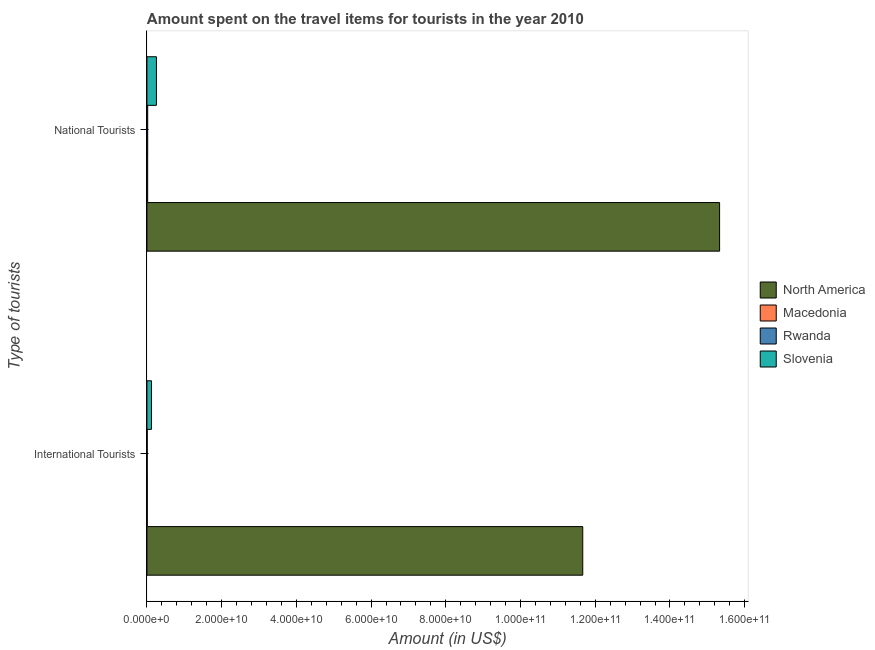How many groups of bars are there?
Offer a terse response. 2. How many bars are there on the 1st tick from the top?
Your response must be concise. 4. What is the label of the 1st group of bars from the top?
Keep it short and to the point. National Tourists. What is the amount spent on travel items of international tourists in Macedonia?
Provide a succinct answer. 9.20e+07. Across all countries, what is the maximum amount spent on travel items of national tourists?
Your answer should be compact. 1.53e+11. Across all countries, what is the minimum amount spent on travel items of international tourists?
Offer a terse response. 7.70e+07. In which country was the amount spent on travel items of national tourists minimum?
Make the answer very short. Macedonia. What is the total amount spent on travel items of international tourists in the graph?
Ensure brevity in your answer.  1.18e+11. What is the difference between the amount spent on travel items of national tourists in Rwanda and that in Slovenia?
Offer a very short reply. -2.34e+09. What is the difference between the amount spent on travel items of national tourists in North America and the amount spent on travel items of international tourists in Slovenia?
Your answer should be very brief. 1.52e+11. What is the average amount spent on travel items of international tourists per country?
Offer a very short reply. 2.95e+1. What is the difference between the amount spent on travel items of international tourists and amount spent on travel items of national tourists in North America?
Your answer should be very brief. -3.66e+1. What is the ratio of the amount spent on travel items of international tourists in Rwanda to that in Macedonia?
Offer a terse response. 0.84. In how many countries, is the amount spent on travel items of international tourists greater than the average amount spent on travel items of international tourists taken over all countries?
Your response must be concise. 1. What does the 1st bar from the top in International Tourists represents?
Offer a very short reply. Slovenia. What does the 4th bar from the bottom in International Tourists represents?
Your response must be concise. Slovenia. Are all the bars in the graph horizontal?
Your response must be concise. Yes. How many countries are there in the graph?
Your answer should be compact. 4. What is the difference between two consecutive major ticks on the X-axis?
Provide a succinct answer. 2.00e+1. Where does the legend appear in the graph?
Make the answer very short. Center right. How are the legend labels stacked?
Provide a short and direct response. Vertical. What is the title of the graph?
Offer a very short reply. Amount spent on the travel items for tourists in the year 2010. What is the label or title of the X-axis?
Make the answer very short. Amount (in US$). What is the label or title of the Y-axis?
Give a very brief answer. Type of tourists. What is the Amount (in US$) in North America in International Tourists?
Your response must be concise. 1.17e+11. What is the Amount (in US$) in Macedonia in International Tourists?
Your response must be concise. 9.20e+07. What is the Amount (in US$) of Rwanda in International Tourists?
Give a very brief answer. 7.70e+07. What is the Amount (in US$) of Slovenia in International Tourists?
Provide a succinct answer. 1.21e+09. What is the Amount (in US$) in North America in National Tourists?
Your answer should be compact. 1.53e+11. What is the Amount (in US$) of Macedonia in National Tourists?
Your answer should be compact. 1.97e+08. What is the Amount (in US$) of Rwanda in National Tourists?
Offer a very short reply. 2.02e+08. What is the Amount (in US$) of Slovenia in National Tourists?
Make the answer very short. 2.54e+09. Across all Type of tourists, what is the maximum Amount (in US$) of North America?
Ensure brevity in your answer.  1.53e+11. Across all Type of tourists, what is the maximum Amount (in US$) of Macedonia?
Your answer should be very brief. 1.97e+08. Across all Type of tourists, what is the maximum Amount (in US$) of Rwanda?
Make the answer very short. 2.02e+08. Across all Type of tourists, what is the maximum Amount (in US$) of Slovenia?
Offer a terse response. 2.54e+09. Across all Type of tourists, what is the minimum Amount (in US$) in North America?
Make the answer very short. 1.17e+11. Across all Type of tourists, what is the minimum Amount (in US$) in Macedonia?
Make the answer very short. 9.20e+07. Across all Type of tourists, what is the minimum Amount (in US$) of Rwanda?
Your answer should be very brief. 7.70e+07. Across all Type of tourists, what is the minimum Amount (in US$) of Slovenia?
Make the answer very short. 1.21e+09. What is the total Amount (in US$) of North America in the graph?
Your answer should be compact. 2.70e+11. What is the total Amount (in US$) in Macedonia in the graph?
Give a very brief answer. 2.89e+08. What is the total Amount (in US$) of Rwanda in the graph?
Offer a very short reply. 2.79e+08. What is the total Amount (in US$) in Slovenia in the graph?
Your answer should be very brief. 3.75e+09. What is the difference between the Amount (in US$) of North America in International Tourists and that in National Tourists?
Offer a very short reply. -3.66e+1. What is the difference between the Amount (in US$) in Macedonia in International Tourists and that in National Tourists?
Offer a terse response. -1.05e+08. What is the difference between the Amount (in US$) of Rwanda in International Tourists and that in National Tourists?
Give a very brief answer. -1.25e+08. What is the difference between the Amount (in US$) of Slovenia in International Tourists and that in National Tourists?
Your response must be concise. -1.33e+09. What is the difference between the Amount (in US$) in North America in International Tourists and the Amount (in US$) in Macedonia in National Tourists?
Make the answer very short. 1.16e+11. What is the difference between the Amount (in US$) in North America in International Tourists and the Amount (in US$) in Rwanda in National Tourists?
Give a very brief answer. 1.16e+11. What is the difference between the Amount (in US$) in North America in International Tourists and the Amount (in US$) in Slovenia in National Tourists?
Make the answer very short. 1.14e+11. What is the difference between the Amount (in US$) in Macedonia in International Tourists and the Amount (in US$) in Rwanda in National Tourists?
Your response must be concise. -1.10e+08. What is the difference between the Amount (in US$) in Macedonia in International Tourists and the Amount (in US$) in Slovenia in National Tourists?
Provide a succinct answer. -2.45e+09. What is the difference between the Amount (in US$) of Rwanda in International Tourists and the Amount (in US$) of Slovenia in National Tourists?
Make the answer very short. -2.46e+09. What is the average Amount (in US$) in North America per Type of tourists?
Offer a terse response. 1.35e+11. What is the average Amount (in US$) in Macedonia per Type of tourists?
Offer a very short reply. 1.44e+08. What is the average Amount (in US$) of Rwanda per Type of tourists?
Keep it short and to the point. 1.40e+08. What is the average Amount (in US$) in Slovenia per Type of tourists?
Make the answer very short. 1.88e+09. What is the difference between the Amount (in US$) in North America and Amount (in US$) in Macedonia in International Tourists?
Provide a succinct answer. 1.17e+11. What is the difference between the Amount (in US$) in North America and Amount (in US$) in Rwanda in International Tourists?
Offer a very short reply. 1.17e+11. What is the difference between the Amount (in US$) in North America and Amount (in US$) in Slovenia in International Tourists?
Provide a short and direct response. 1.15e+11. What is the difference between the Amount (in US$) in Macedonia and Amount (in US$) in Rwanda in International Tourists?
Make the answer very short. 1.50e+07. What is the difference between the Amount (in US$) of Macedonia and Amount (in US$) of Slovenia in International Tourists?
Offer a terse response. -1.12e+09. What is the difference between the Amount (in US$) in Rwanda and Amount (in US$) in Slovenia in International Tourists?
Provide a short and direct response. -1.14e+09. What is the difference between the Amount (in US$) of North America and Amount (in US$) of Macedonia in National Tourists?
Provide a succinct answer. 1.53e+11. What is the difference between the Amount (in US$) of North America and Amount (in US$) of Rwanda in National Tourists?
Provide a short and direct response. 1.53e+11. What is the difference between the Amount (in US$) of North America and Amount (in US$) of Slovenia in National Tourists?
Provide a short and direct response. 1.51e+11. What is the difference between the Amount (in US$) in Macedonia and Amount (in US$) in Rwanda in National Tourists?
Offer a very short reply. -5.00e+06. What is the difference between the Amount (in US$) of Macedonia and Amount (in US$) of Slovenia in National Tourists?
Provide a succinct answer. -2.34e+09. What is the difference between the Amount (in US$) of Rwanda and Amount (in US$) of Slovenia in National Tourists?
Give a very brief answer. -2.34e+09. What is the ratio of the Amount (in US$) in North America in International Tourists to that in National Tourists?
Your answer should be very brief. 0.76. What is the ratio of the Amount (in US$) of Macedonia in International Tourists to that in National Tourists?
Keep it short and to the point. 0.47. What is the ratio of the Amount (in US$) in Rwanda in International Tourists to that in National Tourists?
Ensure brevity in your answer.  0.38. What is the ratio of the Amount (in US$) in Slovenia in International Tourists to that in National Tourists?
Provide a short and direct response. 0.48. What is the difference between the highest and the second highest Amount (in US$) of North America?
Offer a terse response. 3.66e+1. What is the difference between the highest and the second highest Amount (in US$) of Macedonia?
Ensure brevity in your answer.  1.05e+08. What is the difference between the highest and the second highest Amount (in US$) in Rwanda?
Your answer should be compact. 1.25e+08. What is the difference between the highest and the second highest Amount (in US$) of Slovenia?
Provide a short and direct response. 1.33e+09. What is the difference between the highest and the lowest Amount (in US$) of North America?
Offer a very short reply. 3.66e+1. What is the difference between the highest and the lowest Amount (in US$) in Macedonia?
Provide a short and direct response. 1.05e+08. What is the difference between the highest and the lowest Amount (in US$) of Rwanda?
Make the answer very short. 1.25e+08. What is the difference between the highest and the lowest Amount (in US$) in Slovenia?
Give a very brief answer. 1.33e+09. 